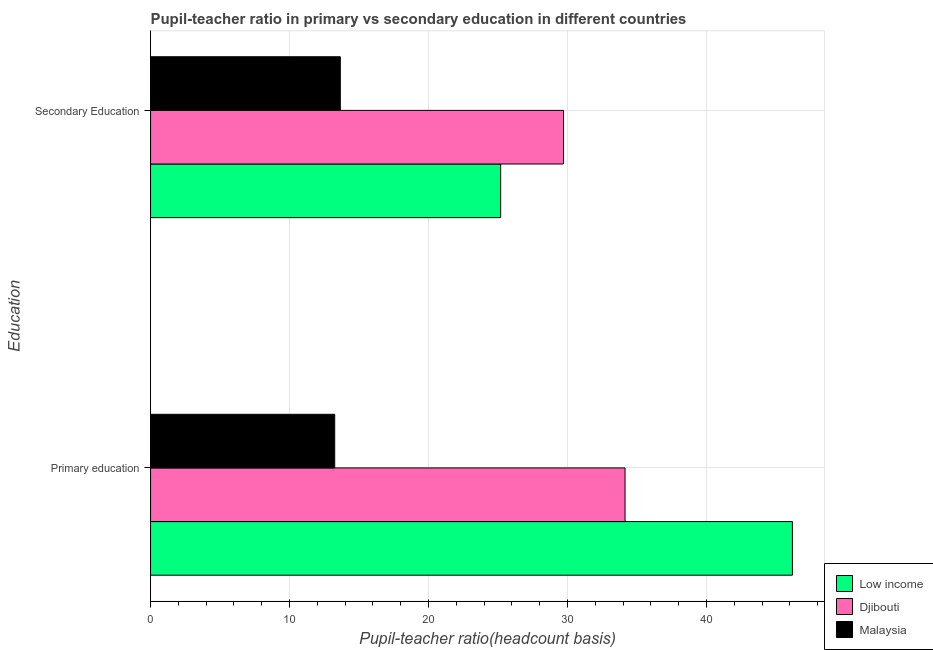How many groups of bars are there?
Your answer should be compact. 2. How many bars are there on the 1st tick from the bottom?
Provide a succinct answer. 3. What is the label of the 2nd group of bars from the top?
Offer a terse response. Primary education. What is the pupil-teacher ratio in primary education in Malaysia?
Offer a terse response. 13.25. Across all countries, what is the maximum pupil teacher ratio on secondary education?
Ensure brevity in your answer.  29.71. Across all countries, what is the minimum pupil-teacher ratio in primary education?
Your answer should be very brief. 13.25. In which country was the pupil teacher ratio on secondary education maximum?
Provide a succinct answer. Djibouti. In which country was the pupil teacher ratio on secondary education minimum?
Your answer should be compact. Malaysia. What is the total pupil teacher ratio on secondary education in the graph?
Keep it short and to the point. 68.56. What is the difference between the pupil-teacher ratio in primary education in Malaysia and that in Low income?
Your answer should be very brief. -32.93. What is the difference between the pupil teacher ratio on secondary education in Djibouti and the pupil-teacher ratio in primary education in Malaysia?
Give a very brief answer. 16.46. What is the average pupil-teacher ratio in primary education per country?
Provide a short and direct response. 31.19. What is the difference between the pupil-teacher ratio in primary education and pupil teacher ratio on secondary education in Malaysia?
Provide a short and direct response. -0.4. In how many countries, is the pupil teacher ratio on secondary education greater than 8 ?
Your response must be concise. 3. What is the ratio of the pupil-teacher ratio in primary education in Djibouti to that in Low income?
Offer a terse response. 0.74. In how many countries, is the pupil teacher ratio on secondary education greater than the average pupil teacher ratio on secondary education taken over all countries?
Your response must be concise. 2. What does the 3rd bar from the top in Secondary Education represents?
Provide a succinct answer. Low income. What does the 2nd bar from the bottom in Secondary Education represents?
Your answer should be very brief. Djibouti. How many bars are there?
Give a very brief answer. 6. How many countries are there in the graph?
Provide a succinct answer. 3. Are the values on the major ticks of X-axis written in scientific E-notation?
Give a very brief answer. No. Does the graph contain grids?
Your answer should be very brief. Yes. Where does the legend appear in the graph?
Offer a terse response. Bottom right. How are the legend labels stacked?
Keep it short and to the point. Vertical. What is the title of the graph?
Give a very brief answer. Pupil-teacher ratio in primary vs secondary education in different countries. Does "Bhutan" appear as one of the legend labels in the graph?
Your answer should be compact. No. What is the label or title of the X-axis?
Offer a very short reply. Pupil-teacher ratio(headcount basis). What is the label or title of the Y-axis?
Your response must be concise. Education. What is the Pupil-teacher ratio(headcount basis) of Low income in Primary education?
Your response must be concise. 46.18. What is the Pupil-teacher ratio(headcount basis) of Djibouti in Primary education?
Your answer should be very brief. 34.14. What is the Pupil-teacher ratio(headcount basis) in Malaysia in Primary education?
Offer a very short reply. 13.25. What is the Pupil-teacher ratio(headcount basis) in Low income in Secondary Education?
Offer a very short reply. 25.19. What is the Pupil-teacher ratio(headcount basis) in Djibouti in Secondary Education?
Your answer should be compact. 29.71. What is the Pupil-teacher ratio(headcount basis) in Malaysia in Secondary Education?
Give a very brief answer. 13.65. Across all Education, what is the maximum Pupil-teacher ratio(headcount basis) of Low income?
Ensure brevity in your answer.  46.18. Across all Education, what is the maximum Pupil-teacher ratio(headcount basis) of Djibouti?
Offer a terse response. 34.14. Across all Education, what is the maximum Pupil-teacher ratio(headcount basis) of Malaysia?
Provide a succinct answer. 13.65. Across all Education, what is the minimum Pupil-teacher ratio(headcount basis) in Low income?
Your answer should be compact. 25.19. Across all Education, what is the minimum Pupil-teacher ratio(headcount basis) in Djibouti?
Make the answer very short. 29.71. Across all Education, what is the minimum Pupil-teacher ratio(headcount basis) of Malaysia?
Your answer should be compact. 13.25. What is the total Pupil-teacher ratio(headcount basis) of Low income in the graph?
Your answer should be very brief. 71.37. What is the total Pupil-teacher ratio(headcount basis) in Djibouti in the graph?
Your response must be concise. 63.85. What is the total Pupil-teacher ratio(headcount basis) of Malaysia in the graph?
Your answer should be compact. 26.9. What is the difference between the Pupil-teacher ratio(headcount basis) of Low income in Primary education and that in Secondary Education?
Provide a short and direct response. 20.99. What is the difference between the Pupil-teacher ratio(headcount basis) in Djibouti in Primary education and that in Secondary Education?
Keep it short and to the point. 4.43. What is the difference between the Pupil-teacher ratio(headcount basis) in Malaysia in Primary education and that in Secondary Education?
Give a very brief answer. -0.4. What is the difference between the Pupil-teacher ratio(headcount basis) of Low income in Primary education and the Pupil-teacher ratio(headcount basis) of Djibouti in Secondary Education?
Give a very brief answer. 16.47. What is the difference between the Pupil-teacher ratio(headcount basis) of Low income in Primary education and the Pupil-teacher ratio(headcount basis) of Malaysia in Secondary Education?
Ensure brevity in your answer.  32.53. What is the difference between the Pupil-teacher ratio(headcount basis) in Djibouti in Primary education and the Pupil-teacher ratio(headcount basis) in Malaysia in Secondary Education?
Your response must be concise. 20.49. What is the average Pupil-teacher ratio(headcount basis) of Low income per Education?
Provide a short and direct response. 35.69. What is the average Pupil-teacher ratio(headcount basis) of Djibouti per Education?
Make the answer very short. 31.93. What is the average Pupil-teacher ratio(headcount basis) of Malaysia per Education?
Give a very brief answer. 13.45. What is the difference between the Pupil-teacher ratio(headcount basis) in Low income and Pupil-teacher ratio(headcount basis) in Djibouti in Primary education?
Ensure brevity in your answer.  12.04. What is the difference between the Pupil-teacher ratio(headcount basis) in Low income and Pupil-teacher ratio(headcount basis) in Malaysia in Primary education?
Offer a terse response. 32.93. What is the difference between the Pupil-teacher ratio(headcount basis) in Djibouti and Pupil-teacher ratio(headcount basis) in Malaysia in Primary education?
Your answer should be compact. 20.89. What is the difference between the Pupil-teacher ratio(headcount basis) of Low income and Pupil-teacher ratio(headcount basis) of Djibouti in Secondary Education?
Your response must be concise. -4.52. What is the difference between the Pupil-teacher ratio(headcount basis) in Low income and Pupil-teacher ratio(headcount basis) in Malaysia in Secondary Education?
Provide a succinct answer. 11.54. What is the difference between the Pupil-teacher ratio(headcount basis) of Djibouti and Pupil-teacher ratio(headcount basis) of Malaysia in Secondary Education?
Provide a succinct answer. 16.06. What is the ratio of the Pupil-teacher ratio(headcount basis) in Low income in Primary education to that in Secondary Education?
Keep it short and to the point. 1.83. What is the ratio of the Pupil-teacher ratio(headcount basis) in Djibouti in Primary education to that in Secondary Education?
Ensure brevity in your answer.  1.15. What is the ratio of the Pupil-teacher ratio(headcount basis) in Malaysia in Primary education to that in Secondary Education?
Keep it short and to the point. 0.97. What is the difference between the highest and the second highest Pupil-teacher ratio(headcount basis) of Low income?
Offer a terse response. 20.99. What is the difference between the highest and the second highest Pupil-teacher ratio(headcount basis) of Djibouti?
Offer a very short reply. 4.43. What is the difference between the highest and the second highest Pupil-teacher ratio(headcount basis) of Malaysia?
Provide a succinct answer. 0.4. What is the difference between the highest and the lowest Pupil-teacher ratio(headcount basis) in Low income?
Provide a succinct answer. 20.99. What is the difference between the highest and the lowest Pupil-teacher ratio(headcount basis) of Djibouti?
Your answer should be compact. 4.43. What is the difference between the highest and the lowest Pupil-teacher ratio(headcount basis) in Malaysia?
Offer a very short reply. 0.4. 